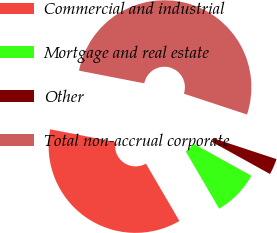Convert chart to OTSL. <chart><loc_0><loc_0><loc_500><loc_500><pie_chart><fcel>Commercial and industrial<fcel>Mortgage and real estate<fcel>Other<fcel>Total non-accrual corporate<nl><fcel>36.47%<fcel>8.53%<fcel>2.98%<fcel>52.02%<nl></chart> 